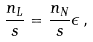Convert formula to latex. <formula><loc_0><loc_0><loc_500><loc_500>\frac { n _ { L } } { s } = \frac { n _ { N } } { s } \epsilon \, ,</formula> 